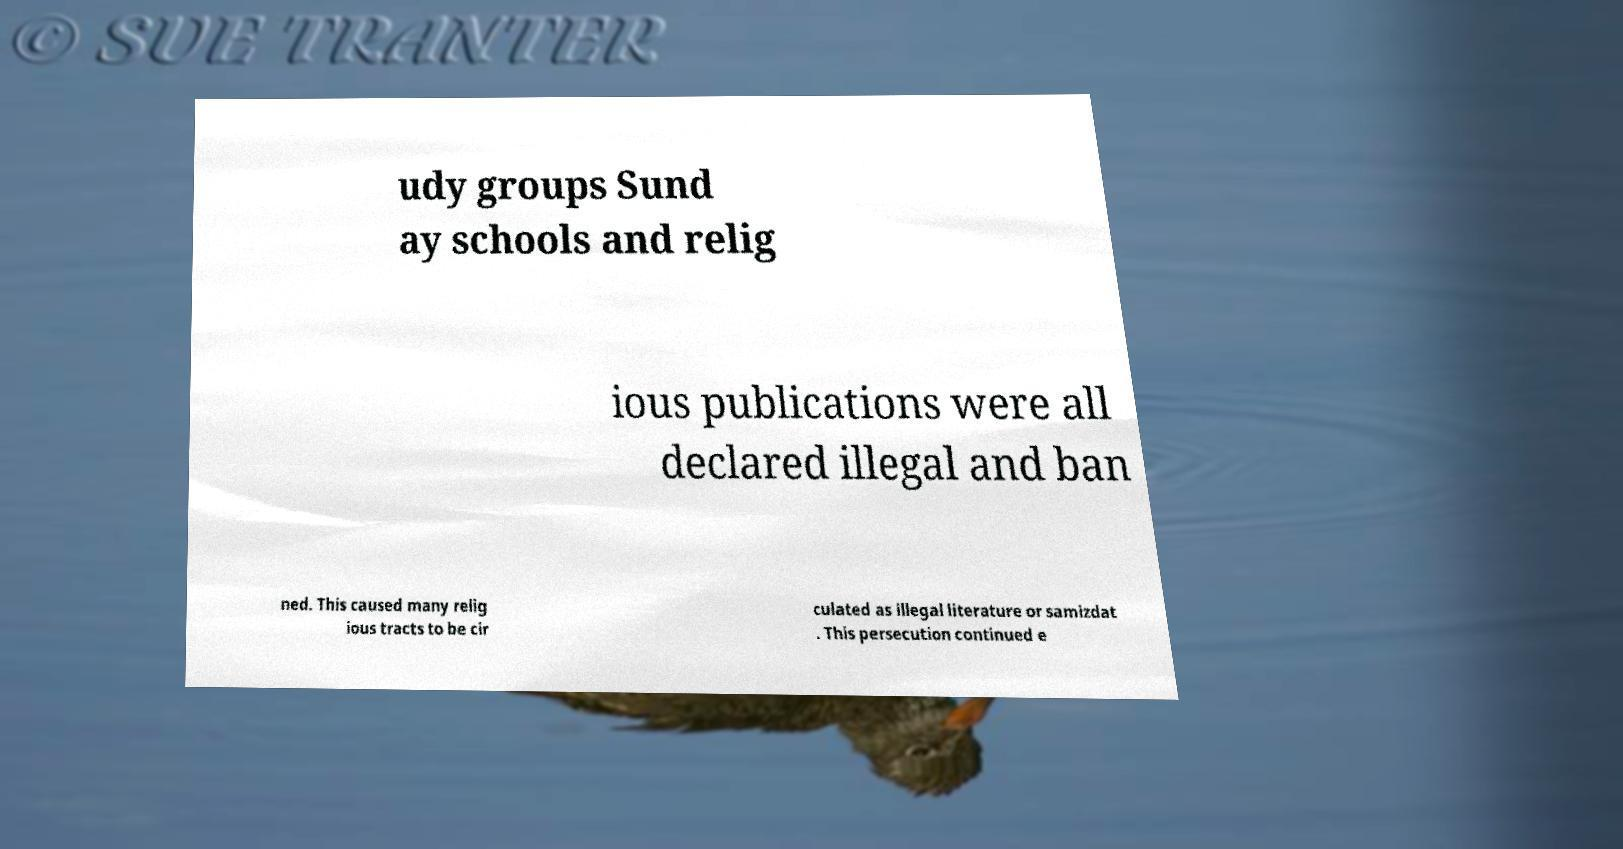Could you assist in decoding the text presented in this image and type it out clearly? udy groups Sund ay schools and relig ious publications were all declared illegal and ban ned. This caused many relig ious tracts to be cir culated as illegal literature or samizdat . This persecution continued e 